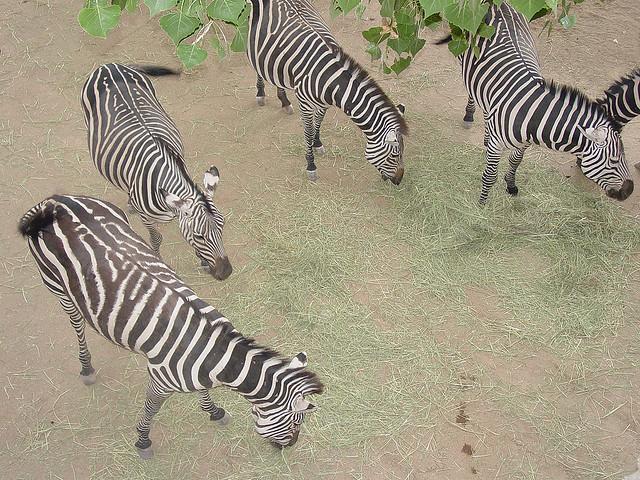How many zebras are there?
Give a very brief answer. 5. Are some of these zebras pregnant?
Short answer required. No. How many zebra's are grazing on grass?
Keep it brief. 5. What are the zebras eating?
Short answer required. Hay. 